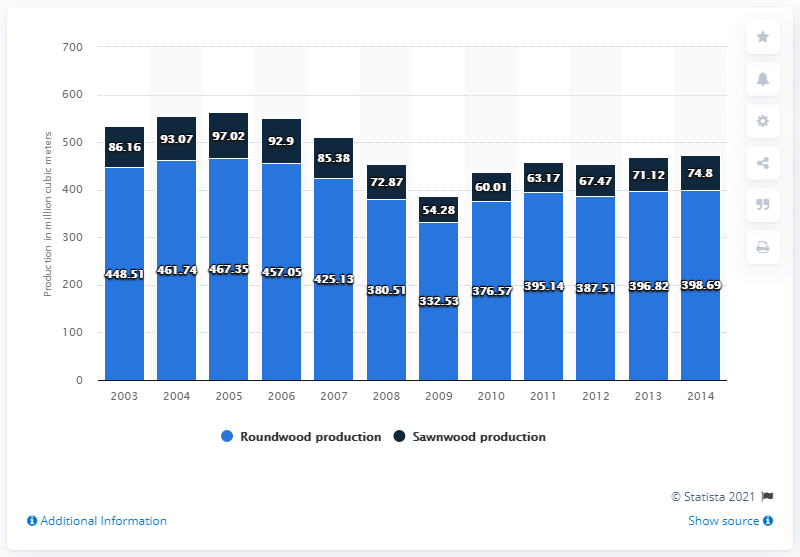Mention a couple of crucial points in this snapshot. In the year 2003, a total of 448.51 cubic meters of roundwood was produced in the United States. 